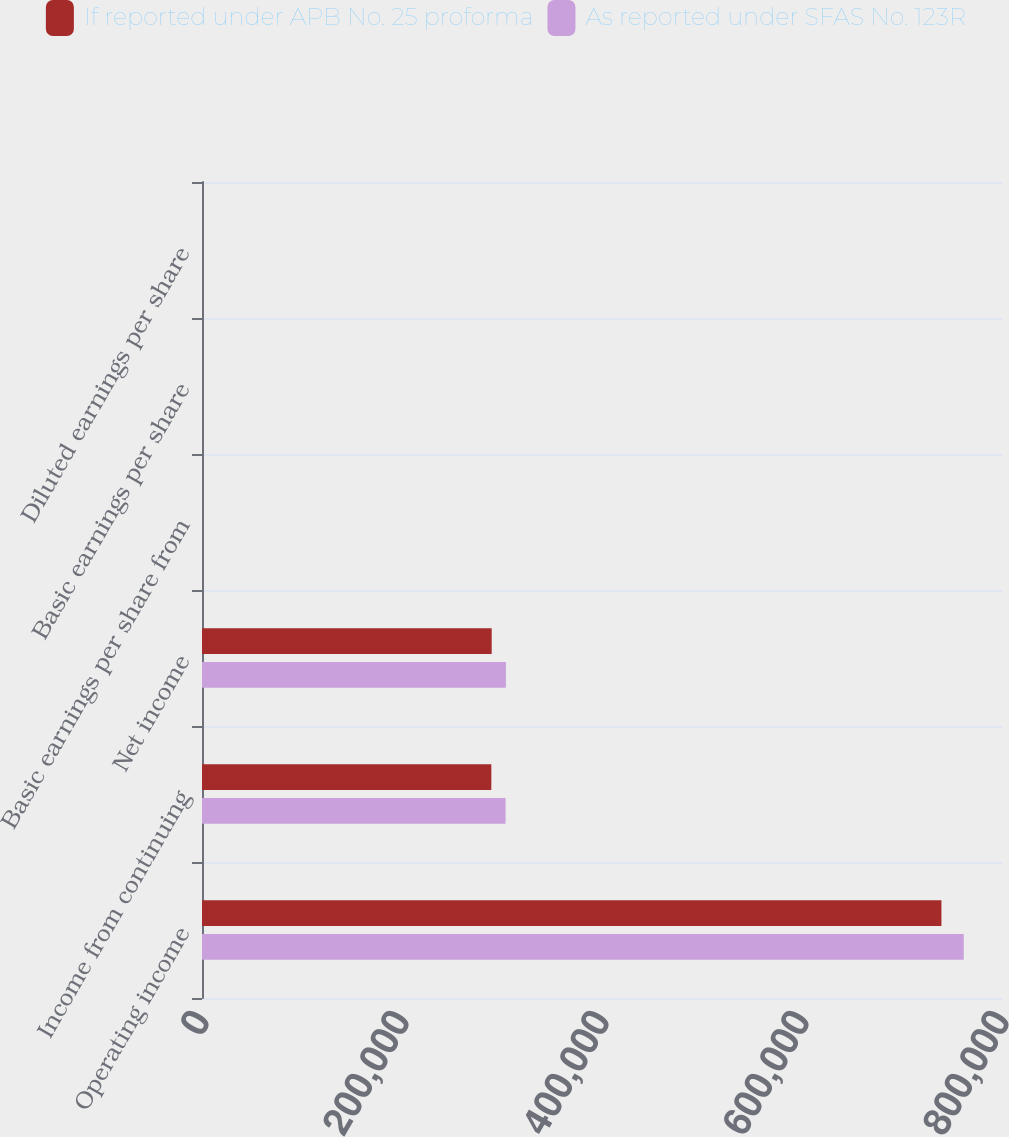<chart> <loc_0><loc_0><loc_500><loc_500><stacked_bar_chart><ecel><fcel>Operating income<fcel>Income from continuing<fcel>Net income<fcel>Basic earnings per share from<fcel>Basic earnings per share<fcel>Diluted earnings per share<nl><fcel>If reported under APB No. 25 proforma<fcel>739432<fcel>289329<fcel>289691<fcel>2.79<fcel>2.8<fcel>2.74<nl><fcel>As reported under SFAS No. 123R<fcel>761752<fcel>303554<fcel>303916<fcel>2.93<fcel>2.94<fcel>2.86<nl></chart> 